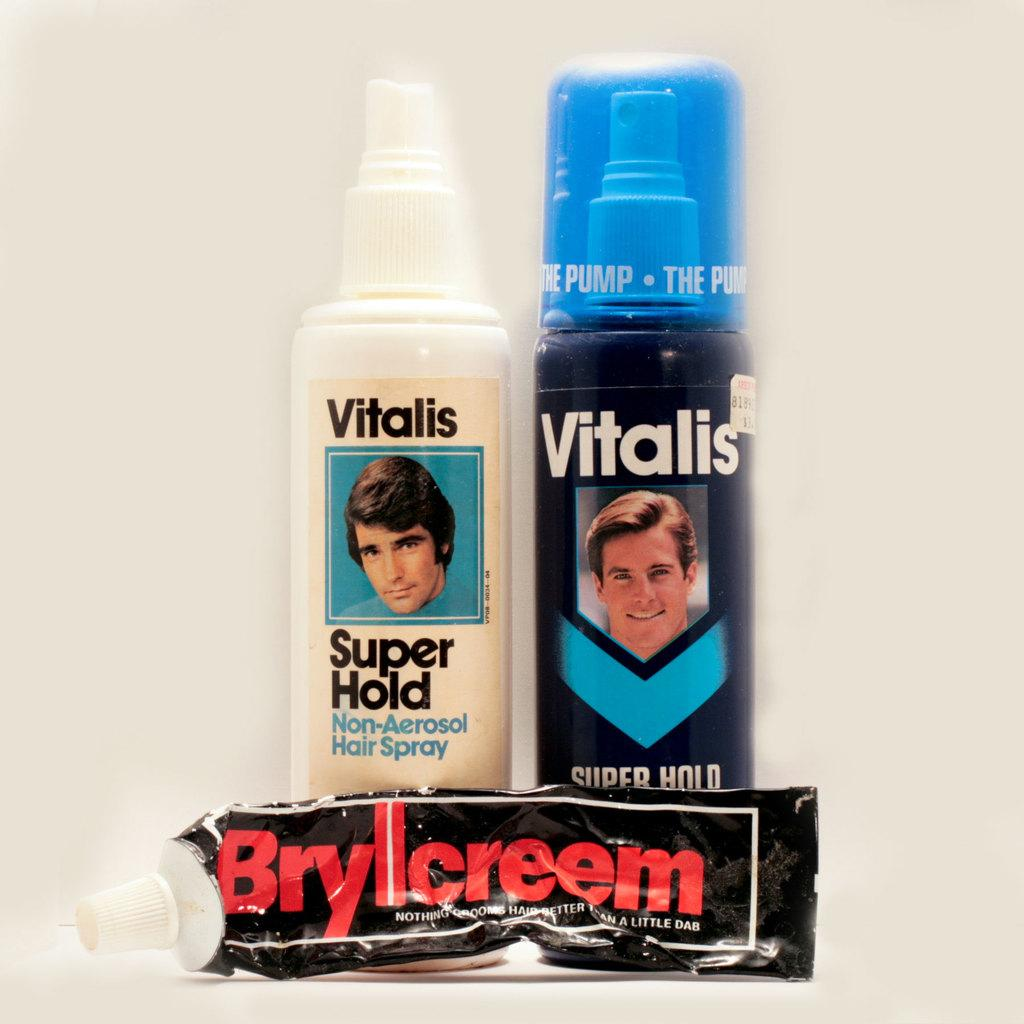<image>
Present a compact description of the photo's key features. Retail pump spay of Vitalis hair spray for men. 